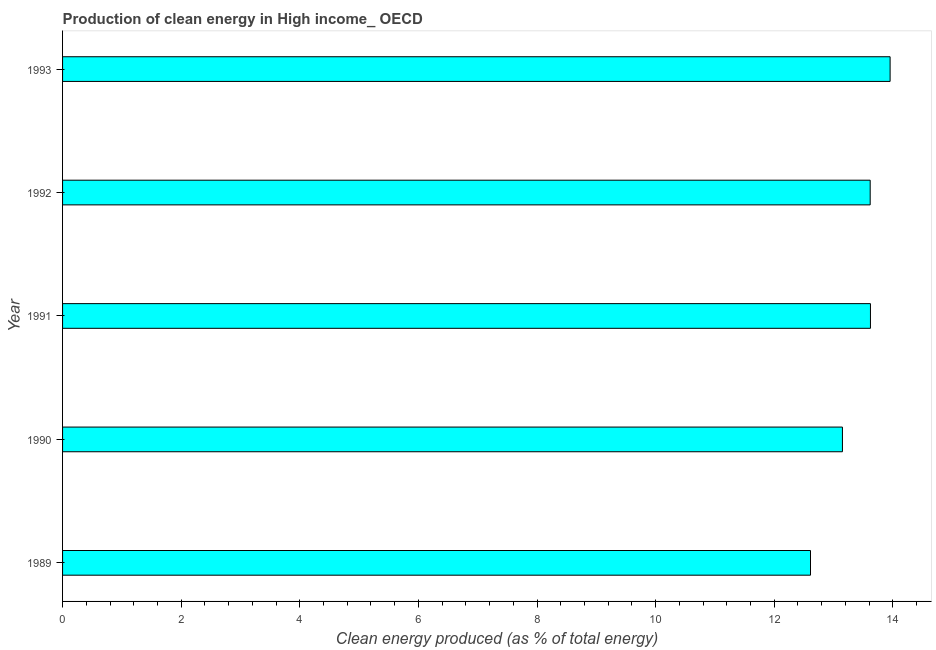What is the title of the graph?
Your answer should be compact. Production of clean energy in High income_ OECD. What is the label or title of the X-axis?
Provide a short and direct response. Clean energy produced (as % of total energy). What is the label or title of the Y-axis?
Provide a short and direct response. Year. What is the production of clean energy in 1991?
Your answer should be very brief. 13.62. Across all years, what is the maximum production of clean energy?
Your response must be concise. 13.95. Across all years, what is the minimum production of clean energy?
Offer a very short reply. 12.61. What is the sum of the production of clean energy?
Your answer should be very brief. 66.96. What is the difference between the production of clean energy in 1991 and 1992?
Ensure brevity in your answer.  0.01. What is the average production of clean energy per year?
Offer a terse response. 13.39. What is the median production of clean energy?
Provide a succinct answer. 13.62. In how many years, is the production of clean energy greater than 12 %?
Your answer should be very brief. 5. Is the production of clean energy in 1991 less than that in 1993?
Offer a terse response. Yes. What is the difference between the highest and the second highest production of clean energy?
Offer a terse response. 0.33. What is the difference between the highest and the lowest production of clean energy?
Offer a very short reply. 1.34. How many bars are there?
Offer a terse response. 5. Are all the bars in the graph horizontal?
Your response must be concise. Yes. How many years are there in the graph?
Provide a short and direct response. 5. What is the difference between two consecutive major ticks on the X-axis?
Your response must be concise. 2. Are the values on the major ticks of X-axis written in scientific E-notation?
Provide a succinct answer. No. What is the Clean energy produced (as % of total energy) in 1989?
Offer a very short reply. 12.61. What is the Clean energy produced (as % of total energy) of 1990?
Your answer should be compact. 13.15. What is the Clean energy produced (as % of total energy) in 1991?
Offer a very short reply. 13.62. What is the Clean energy produced (as % of total energy) in 1992?
Provide a succinct answer. 13.62. What is the Clean energy produced (as % of total energy) of 1993?
Your response must be concise. 13.95. What is the difference between the Clean energy produced (as % of total energy) in 1989 and 1990?
Provide a succinct answer. -0.54. What is the difference between the Clean energy produced (as % of total energy) in 1989 and 1991?
Give a very brief answer. -1.01. What is the difference between the Clean energy produced (as % of total energy) in 1989 and 1992?
Keep it short and to the point. -1.01. What is the difference between the Clean energy produced (as % of total energy) in 1989 and 1993?
Your response must be concise. -1.34. What is the difference between the Clean energy produced (as % of total energy) in 1990 and 1991?
Provide a short and direct response. -0.47. What is the difference between the Clean energy produced (as % of total energy) in 1990 and 1992?
Give a very brief answer. -0.47. What is the difference between the Clean energy produced (as % of total energy) in 1990 and 1993?
Offer a terse response. -0.8. What is the difference between the Clean energy produced (as % of total energy) in 1991 and 1992?
Your answer should be compact. 0. What is the difference between the Clean energy produced (as % of total energy) in 1991 and 1993?
Provide a short and direct response. -0.33. What is the difference between the Clean energy produced (as % of total energy) in 1992 and 1993?
Your answer should be compact. -0.34. What is the ratio of the Clean energy produced (as % of total energy) in 1989 to that in 1990?
Offer a very short reply. 0.96. What is the ratio of the Clean energy produced (as % of total energy) in 1989 to that in 1991?
Offer a very short reply. 0.93. What is the ratio of the Clean energy produced (as % of total energy) in 1989 to that in 1992?
Make the answer very short. 0.93. What is the ratio of the Clean energy produced (as % of total energy) in 1989 to that in 1993?
Make the answer very short. 0.9. What is the ratio of the Clean energy produced (as % of total energy) in 1990 to that in 1991?
Provide a succinct answer. 0.96. What is the ratio of the Clean energy produced (as % of total energy) in 1990 to that in 1992?
Your answer should be very brief. 0.97. What is the ratio of the Clean energy produced (as % of total energy) in 1990 to that in 1993?
Your answer should be compact. 0.94. What is the ratio of the Clean energy produced (as % of total energy) in 1991 to that in 1993?
Offer a very short reply. 0.98. 